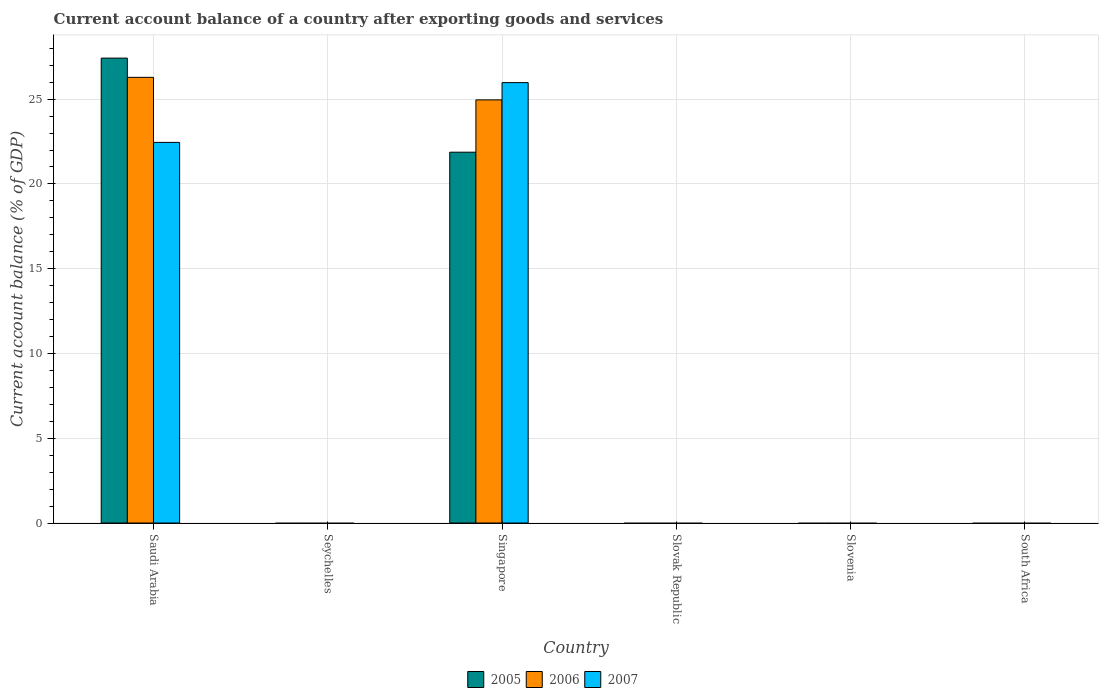How many different coloured bars are there?
Provide a succinct answer. 3. How many bars are there on the 4th tick from the left?
Your answer should be compact. 0. How many bars are there on the 5th tick from the right?
Make the answer very short. 0. What is the label of the 4th group of bars from the left?
Give a very brief answer. Slovak Republic. What is the account balance in 2005 in Saudi Arabia?
Offer a very short reply. 27.42. Across all countries, what is the maximum account balance in 2005?
Provide a succinct answer. 27.42. Across all countries, what is the minimum account balance in 2006?
Make the answer very short. 0. In which country was the account balance in 2006 maximum?
Ensure brevity in your answer.  Saudi Arabia. What is the total account balance in 2005 in the graph?
Offer a very short reply. 49.29. What is the difference between the account balance in 2006 in South Africa and the account balance in 2005 in Saudi Arabia?
Provide a short and direct response. -27.42. What is the average account balance in 2006 per country?
Your response must be concise. 8.54. What is the difference between the account balance of/in 2007 and account balance of/in 2005 in Singapore?
Your response must be concise. 4.1. In how many countries, is the account balance in 2006 greater than 2 %?
Your answer should be compact. 2. What is the ratio of the account balance in 2007 in Saudi Arabia to that in Singapore?
Keep it short and to the point. 0.86. Is the account balance in 2005 in Saudi Arabia less than that in Singapore?
Make the answer very short. No. What is the difference between the highest and the lowest account balance in 2006?
Offer a very short reply. 26.28. In how many countries, is the account balance in 2005 greater than the average account balance in 2005 taken over all countries?
Provide a succinct answer. 2. Are all the bars in the graph horizontal?
Your answer should be very brief. No. How many countries are there in the graph?
Offer a terse response. 6. Does the graph contain grids?
Provide a short and direct response. Yes. How many legend labels are there?
Offer a very short reply. 3. How are the legend labels stacked?
Provide a succinct answer. Horizontal. What is the title of the graph?
Give a very brief answer. Current account balance of a country after exporting goods and services. What is the label or title of the X-axis?
Make the answer very short. Country. What is the label or title of the Y-axis?
Make the answer very short. Current account balance (% of GDP). What is the Current account balance (% of GDP) in 2005 in Saudi Arabia?
Offer a very short reply. 27.42. What is the Current account balance (% of GDP) in 2006 in Saudi Arabia?
Give a very brief answer. 26.28. What is the Current account balance (% of GDP) in 2007 in Saudi Arabia?
Keep it short and to the point. 22.45. What is the Current account balance (% of GDP) in 2005 in Seychelles?
Offer a very short reply. 0. What is the Current account balance (% of GDP) of 2006 in Seychelles?
Your answer should be very brief. 0. What is the Current account balance (% of GDP) in 2007 in Seychelles?
Your response must be concise. 0. What is the Current account balance (% of GDP) in 2005 in Singapore?
Provide a succinct answer. 21.87. What is the Current account balance (% of GDP) in 2006 in Singapore?
Provide a succinct answer. 24.96. What is the Current account balance (% of GDP) of 2007 in Singapore?
Your answer should be very brief. 25.97. What is the Current account balance (% of GDP) in 2007 in Slovak Republic?
Your answer should be very brief. 0. What is the Current account balance (% of GDP) of 2007 in Slovenia?
Keep it short and to the point. 0. What is the Current account balance (% of GDP) of 2005 in South Africa?
Your answer should be very brief. 0. Across all countries, what is the maximum Current account balance (% of GDP) in 2005?
Ensure brevity in your answer.  27.42. Across all countries, what is the maximum Current account balance (% of GDP) in 2006?
Offer a terse response. 26.28. Across all countries, what is the maximum Current account balance (% of GDP) of 2007?
Your answer should be compact. 25.97. Across all countries, what is the minimum Current account balance (% of GDP) in 2005?
Your answer should be very brief. 0. Across all countries, what is the minimum Current account balance (% of GDP) in 2006?
Offer a terse response. 0. Across all countries, what is the minimum Current account balance (% of GDP) of 2007?
Offer a terse response. 0. What is the total Current account balance (% of GDP) in 2005 in the graph?
Your response must be concise. 49.29. What is the total Current account balance (% of GDP) of 2006 in the graph?
Your answer should be very brief. 51.24. What is the total Current account balance (% of GDP) of 2007 in the graph?
Offer a very short reply. 48.42. What is the difference between the Current account balance (% of GDP) of 2005 in Saudi Arabia and that in Singapore?
Provide a succinct answer. 5.55. What is the difference between the Current account balance (% of GDP) of 2006 in Saudi Arabia and that in Singapore?
Make the answer very short. 1.33. What is the difference between the Current account balance (% of GDP) of 2007 in Saudi Arabia and that in Singapore?
Make the answer very short. -3.53. What is the difference between the Current account balance (% of GDP) of 2005 in Saudi Arabia and the Current account balance (% of GDP) of 2006 in Singapore?
Keep it short and to the point. 2.46. What is the difference between the Current account balance (% of GDP) of 2005 in Saudi Arabia and the Current account balance (% of GDP) of 2007 in Singapore?
Ensure brevity in your answer.  1.44. What is the difference between the Current account balance (% of GDP) of 2006 in Saudi Arabia and the Current account balance (% of GDP) of 2007 in Singapore?
Provide a short and direct response. 0.31. What is the average Current account balance (% of GDP) in 2005 per country?
Give a very brief answer. 8.21. What is the average Current account balance (% of GDP) of 2006 per country?
Make the answer very short. 8.54. What is the average Current account balance (% of GDP) of 2007 per country?
Give a very brief answer. 8.07. What is the difference between the Current account balance (% of GDP) of 2005 and Current account balance (% of GDP) of 2006 in Saudi Arabia?
Offer a very short reply. 1.13. What is the difference between the Current account balance (% of GDP) in 2005 and Current account balance (% of GDP) in 2007 in Saudi Arabia?
Your answer should be very brief. 4.97. What is the difference between the Current account balance (% of GDP) of 2006 and Current account balance (% of GDP) of 2007 in Saudi Arabia?
Offer a very short reply. 3.84. What is the difference between the Current account balance (% of GDP) of 2005 and Current account balance (% of GDP) of 2006 in Singapore?
Provide a short and direct response. -3.08. What is the difference between the Current account balance (% of GDP) of 2005 and Current account balance (% of GDP) of 2007 in Singapore?
Your answer should be very brief. -4.1. What is the difference between the Current account balance (% of GDP) in 2006 and Current account balance (% of GDP) in 2007 in Singapore?
Offer a very short reply. -1.02. What is the ratio of the Current account balance (% of GDP) in 2005 in Saudi Arabia to that in Singapore?
Give a very brief answer. 1.25. What is the ratio of the Current account balance (% of GDP) in 2006 in Saudi Arabia to that in Singapore?
Offer a very short reply. 1.05. What is the ratio of the Current account balance (% of GDP) of 2007 in Saudi Arabia to that in Singapore?
Your answer should be very brief. 0.86. What is the difference between the highest and the lowest Current account balance (% of GDP) in 2005?
Make the answer very short. 27.42. What is the difference between the highest and the lowest Current account balance (% of GDP) in 2006?
Your answer should be compact. 26.28. What is the difference between the highest and the lowest Current account balance (% of GDP) in 2007?
Give a very brief answer. 25.97. 